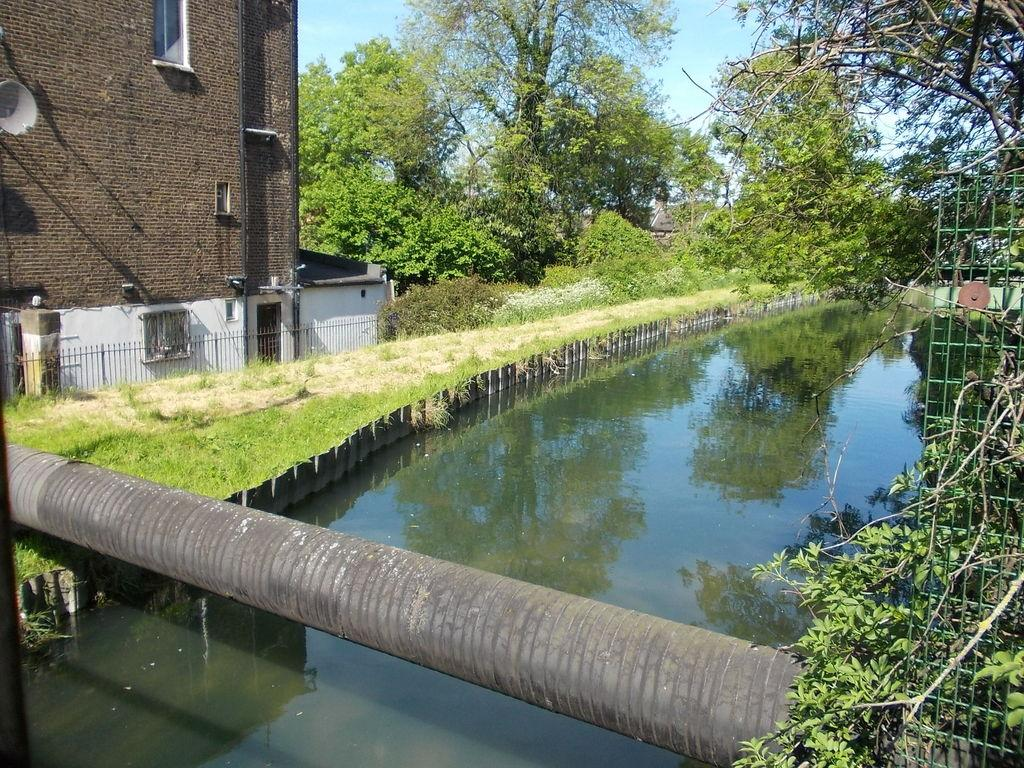What is the primary element visible in the image? There is water in the image. What type of vegetation can be seen in the image? There is green grass and trees in the image. What structures are present in the image? There is a building on the left side of the image and a metal grill on the right side of the image. What man-made feature is visible in the image? There is a pipeline visible in the image. What type of collar can be seen on the north side of the image? There is no collar present in the image, and the concept of "north" is not applicable to a two-dimensional image. 